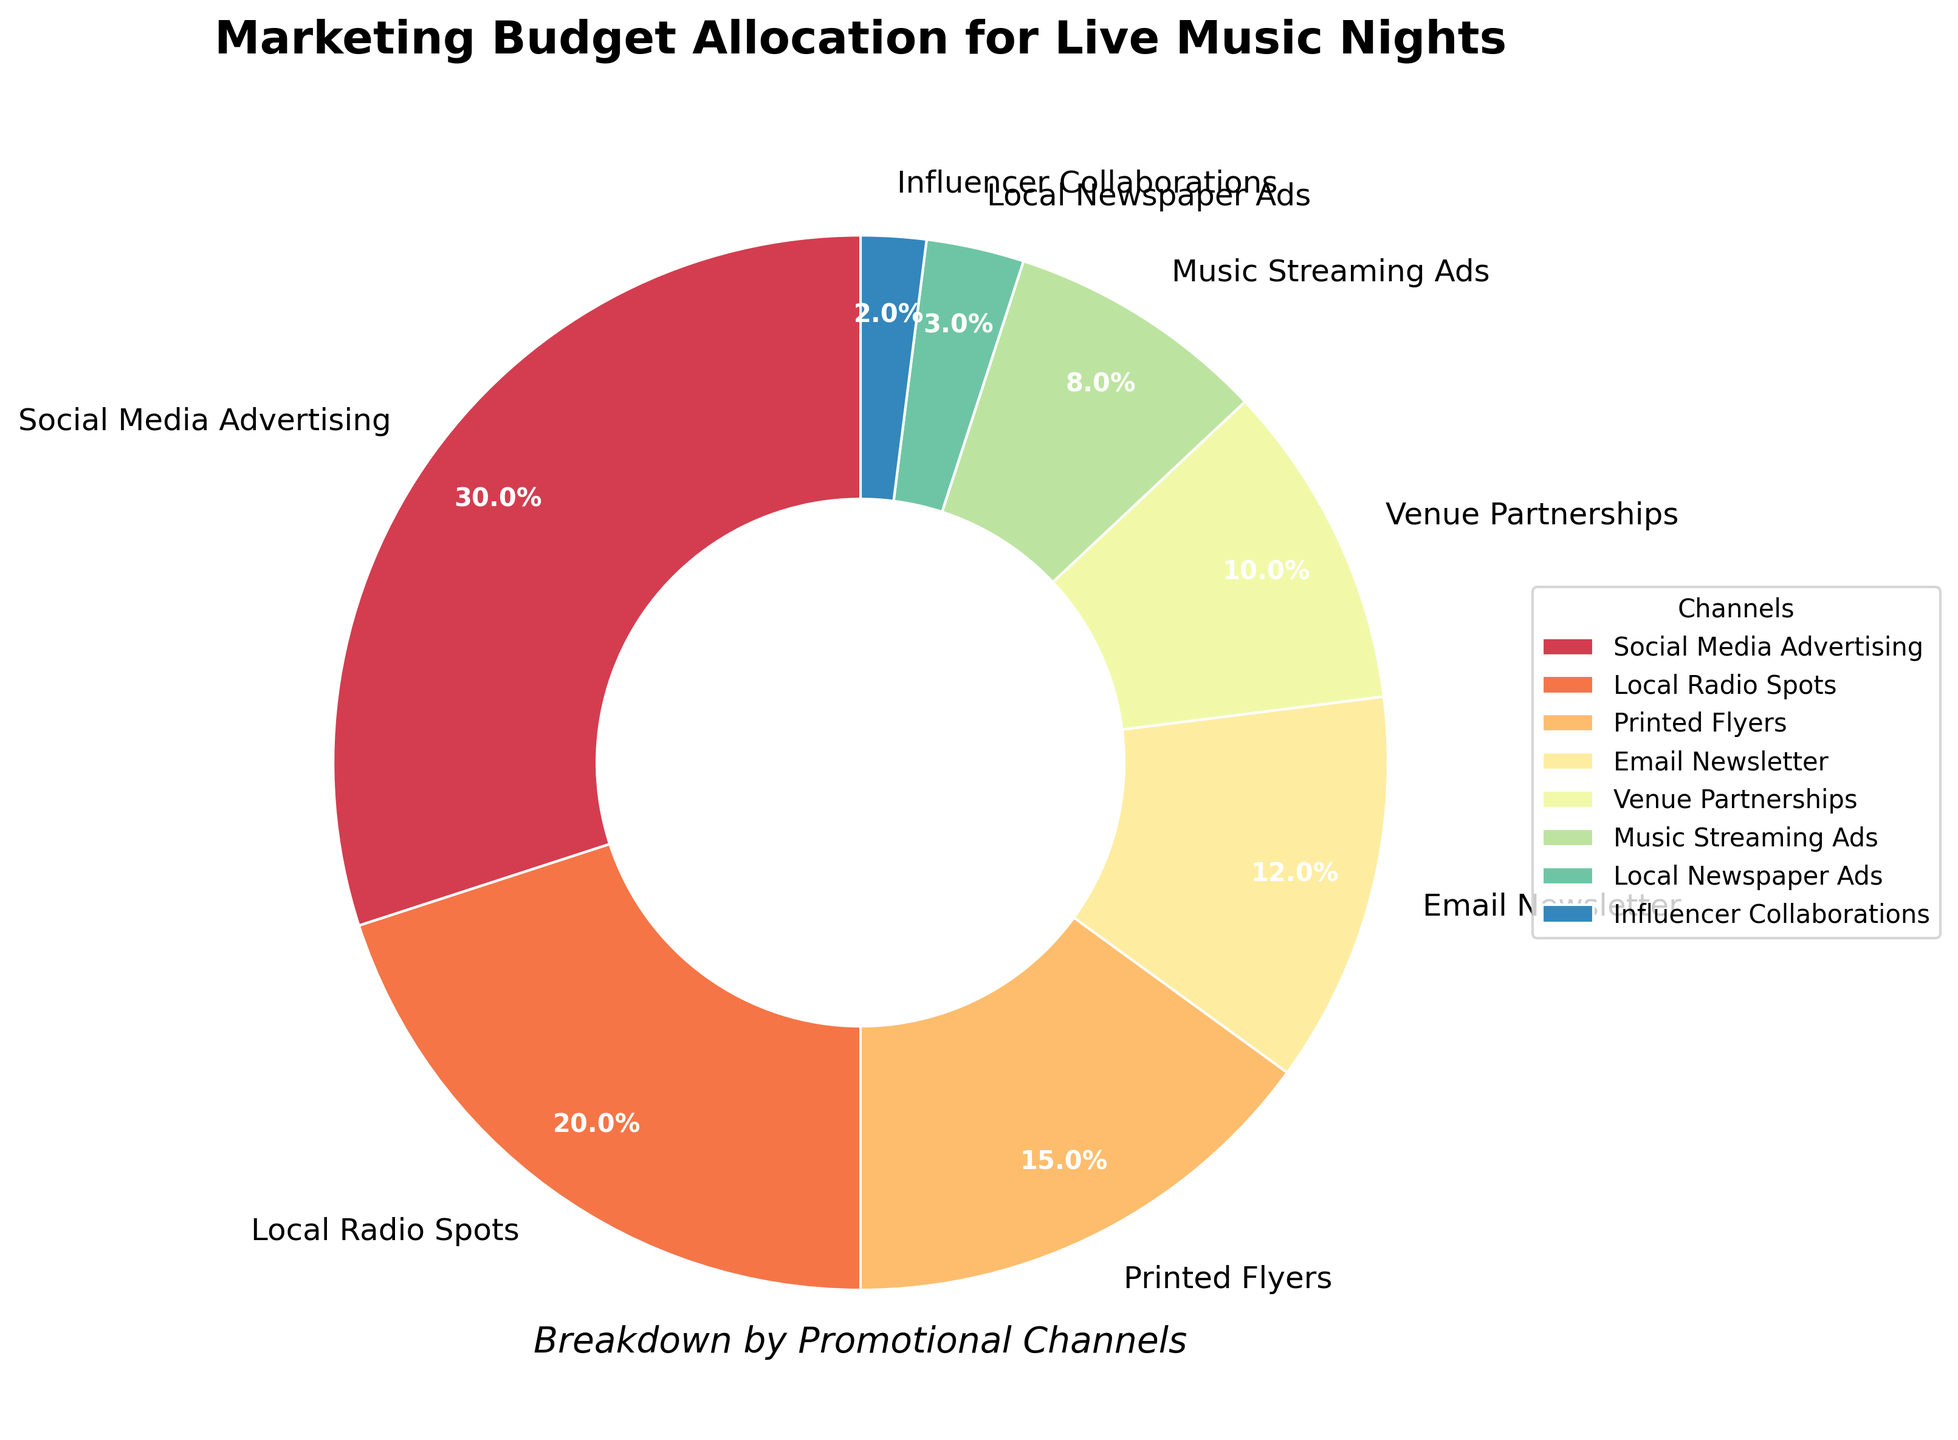What percentage of the marketing budget is allocated to Social Media Advertising and Local Radio Spots combined? To find the combined percentage of Social Media Advertising and Local Radio Spots, add their individual percentages: 30% (Social Media Advertising) + 20% (Local Radio Spots) = 50%.
Answer: 50% Which promotional channel has the smallest share of the marketing budget? By examining the percentages for all the channels, Influencer Collaborations has the smallest share with 2%.
Answer: Influencer Collaborations Are Venue Partnerships allocated more or less budget than Printed Flyers? By how much? Compare the percentages for Venue Partnerships (10%) and Printed Flyers (15%). Subtract the smaller percentage from the larger one to find the difference: 15% - 10% = 5%.
Answer: Less, by 5% What is the total percentage allocated to non-digital channels (Printed Flyers, Local Radio Spots, Local Newspaper Ads)? Sum the percentages for Printed Flyers, Local Radio Spots, and Local Newspaper Ads: 15% (Printed Flyers) + 20% (Local Radio Spots) + 3% (Local Newspaper Ads) = 38%.
Answer: 38% How much more budget is allocated to Email Newsletter compared to Music Streaming Ads? Subtract the percentage for Music Streaming Ads (8%) from the percentage for Email Newsletter (12%): 12% - 8% = 4%.
Answer: 4% Which channel has more budget allocation: Music Streaming Ads or Venue Partnerships? Compare the percentages for Music Streaming Ads (8%) and Venue Partnerships (10%). Venue Partnerships has a higher allocation.
Answer: Venue Partnerships Among Social Media Advertising, Local Radio Spots, and Printed Flyers, which has the highest allocation and by how much compared to the lowest? Examine the percentages: Social Media Advertising (30%), Local Radio Spots (20%), and Printed Flyers (15%). Social Media Advertising has the highest allocation, and Printed Flyers has the lowest. The difference is 30% - 15% = 15%.
Answer: Social Media Advertising, by 15% What is the average percentage allocation for all promotional channels? Sum all the percentages and divide by the number of channels. The total is: 30% + 20% + 15% + 12% + 10% + 8% + 3% + 2% = 100%. The number of channels is 8. Thus, the average is 100% / 8 = 12.5%.
Answer: 12.5% Name three channels that together sum up to about 50% of the budget. Sum the percentages of selected channels to check which combination is around 50%. Choose Local Radio Spots (20%), Printed Flyers (15%), and Email Newsletter (12%): 20% + 15% + 12% = 47%. Another combination could be Local Radio Spots (20%), Venue Partnerships (10%), Music Streaming Ads (8%), and Influencer Collaborations (2%): 20% + 10% + 8% + 2% = 40%. Therefore, the first combination is closer to 50%.
Answer: Local Radio Spots, Printed Flyers, Email Newsletter 